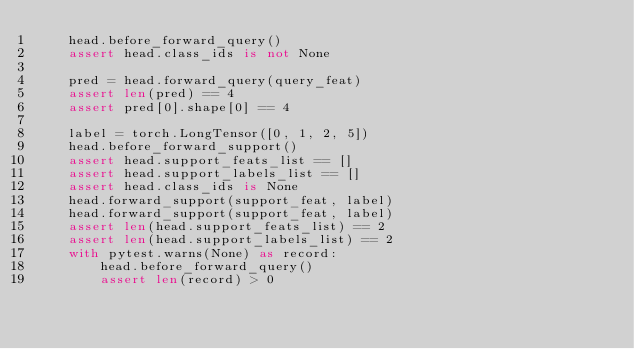Convert code to text. <code><loc_0><loc_0><loc_500><loc_500><_Python_>    head.before_forward_query()
    assert head.class_ids is not None

    pred = head.forward_query(query_feat)
    assert len(pred) == 4
    assert pred[0].shape[0] == 4

    label = torch.LongTensor([0, 1, 2, 5])
    head.before_forward_support()
    assert head.support_feats_list == []
    assert head.support_labels_list == []
    assert head.class_ids is None
    head.forward_support(support_feat, label)
    head.forward_support(support_feat, label)
    assert len(head.support_feats_list) == 2
    assert len(head.support_labels_list) == 2
    with pytest.warns(None) as record:
        head.before_forward_query()
        assert len(record) > 0
</code> 